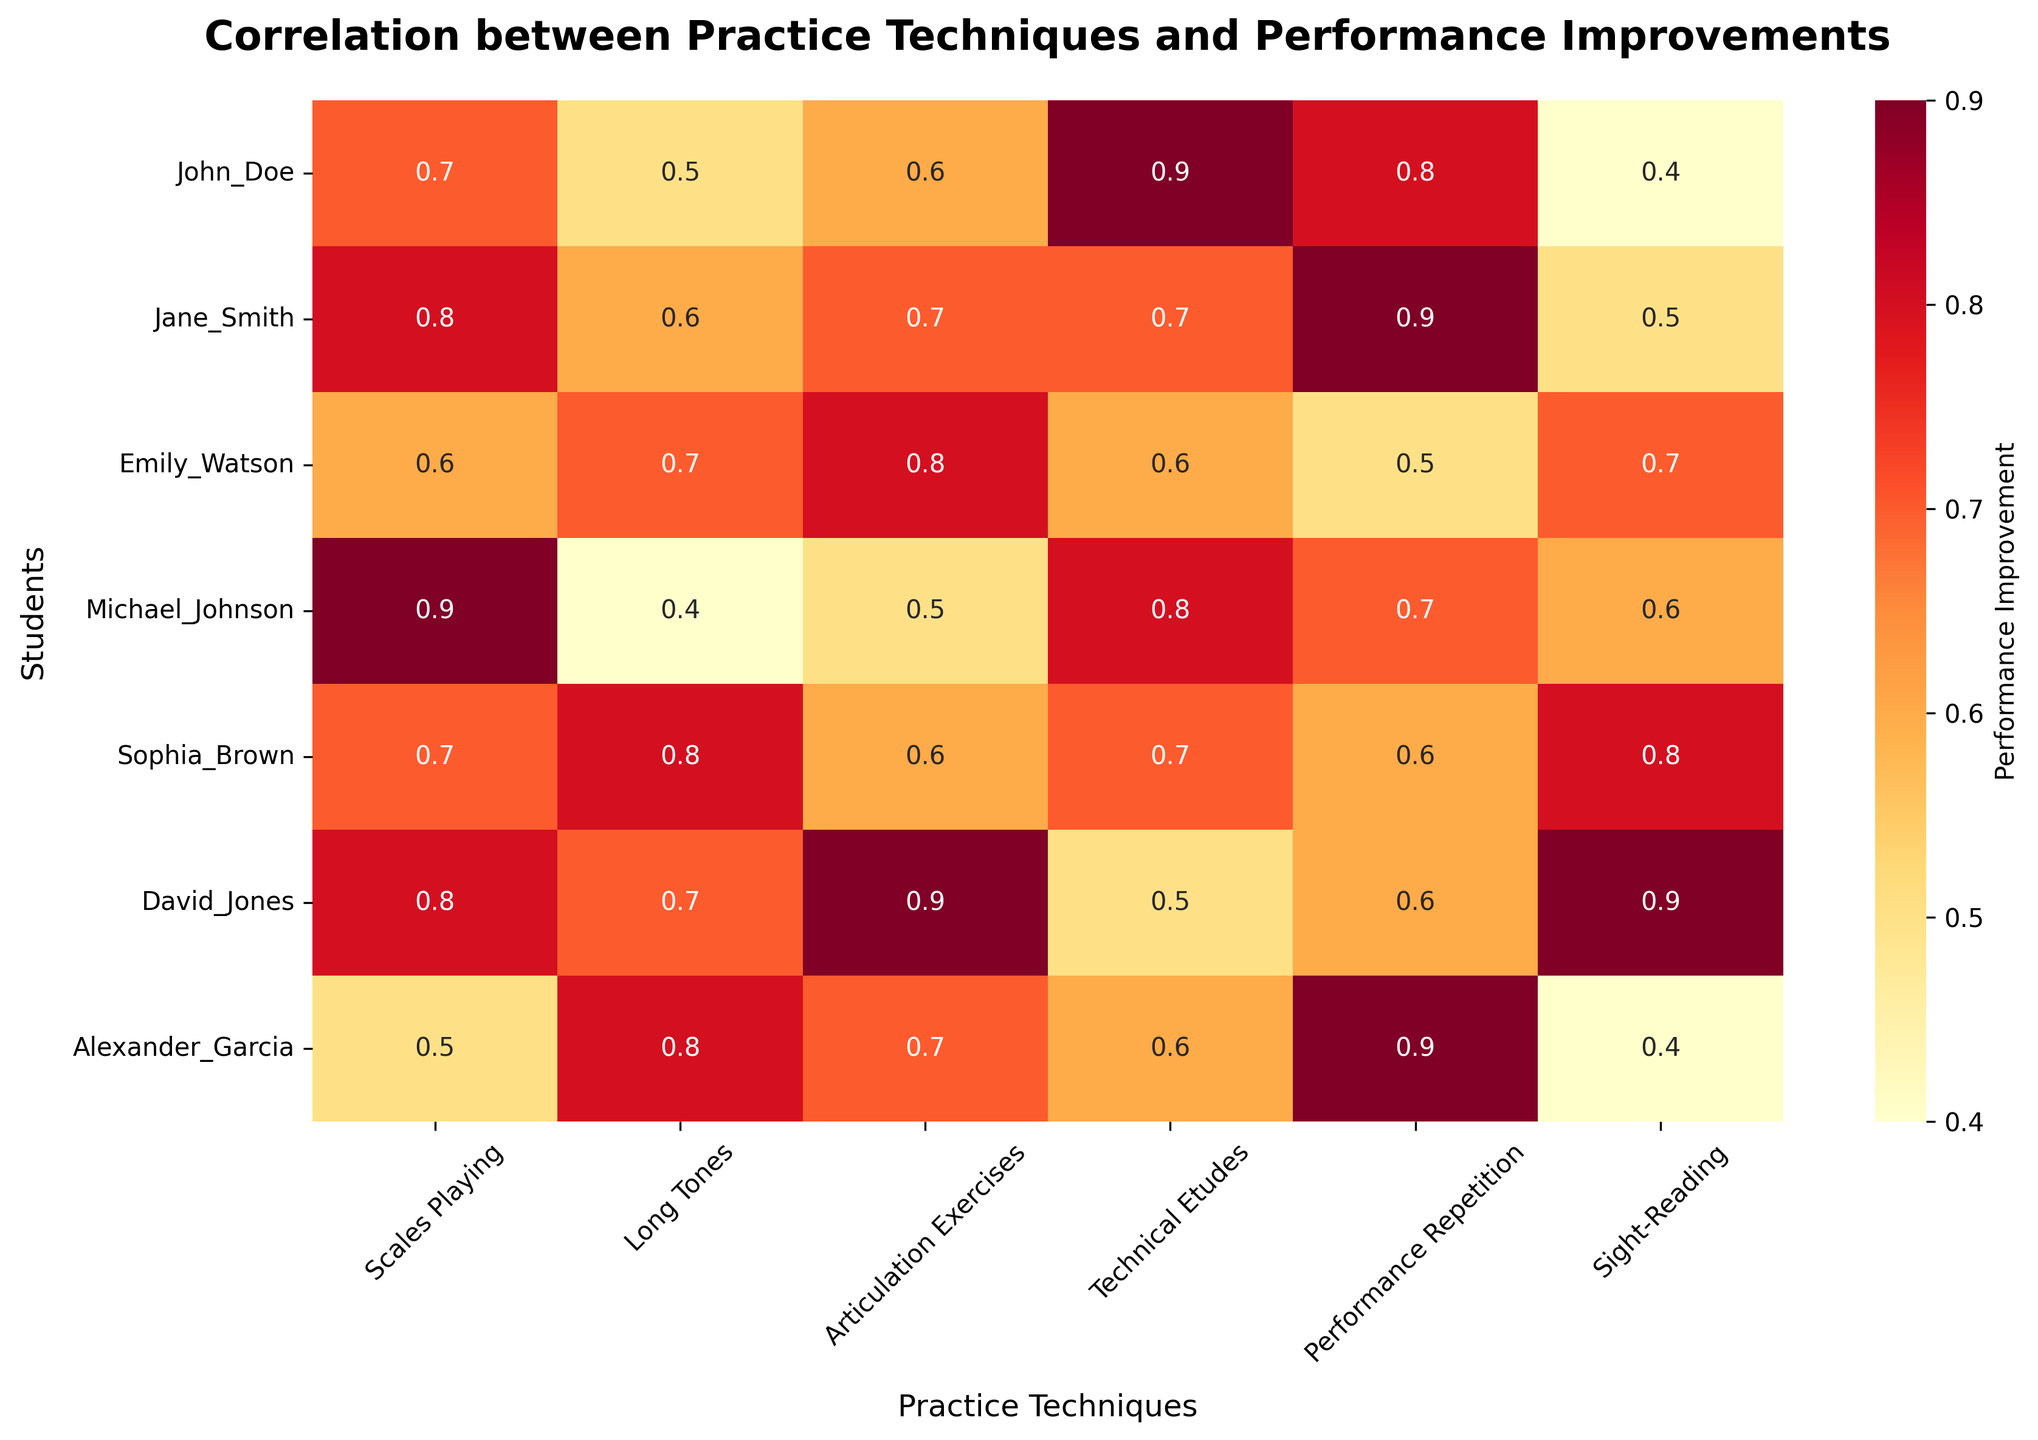What is the title of the heatmap? To identify the title of the heatmap, look at the top of the plot where the title is typically placed. The title summarizes the content of the figure.
Answer: Correlation between Practice Techniques and Performance Improvements Which student shows the highest correlation with Scales Playing? To find which student has the highest correlation with Scales Playing, locate the "Scales Playing" column and identify the highest value. Then, find which student corresponds to this value.
Answer: Michael_Johnson How many practice techniques are analyzed in this heatmap? Count the number of columns in the heatmap excluding the first column, which lists the students' names.
Answer: 6 Which two practice techniques does John_Doe find most beneficial in terms of improving his performance? To determine which two techniques John_Doe finds most beneficial, look at John_Doe's row and identify the two highest correlation values.
Answer: Technical Etudes and Performance Repetition Compare the effectiveness of Long Tones for Jane_Smith and Sophia_Brown. Which one finds it more beneficial? Locate the Long Tones column and compare the values for Jane_Smith and Sophia_Brown. The higher value indicates who finds it more beneficial.
Answer: Sophia_Brown What is the average performance improvement correlation for David_Jones across all techniques? Add the correlation values for David_Jones across all practice techniques and then divide by the number of techniques. (0.8 + 0.7 + 0.9 + 0.5 + 0.6 + 0.9) / 6 = 4.4 / 6 = 0.733
Answer: 0.733 Which practice technique shows the least variation in improvement correlations among students? To identify the technique with the least variation, examine the columns for each technique and compare the ranges (max-min). The smallest range indicates the least variation.
Answer: Long Tones Between Scales Playing and Sight-Reading, which one generally shows a higher correlation with performance improvements? Compare the average correlation values of Scales Playing and Sight-Reading for all students. Summing up the values: Scales Playing (0.7 + 0.8 + 0.6 + 0.9 + 0.7 + 0.8 + 0.5), Sight-Reading (0.4 + 0.5 + 0.7 + 0.6 + 0.8 + 0.9 + 0.4) and take the averages: 5.0/7 ≈ 0.714 for Scales Playing, 4.3/7 ≈ 0.614 for Sight-Reading
Answer: Scales Playing 